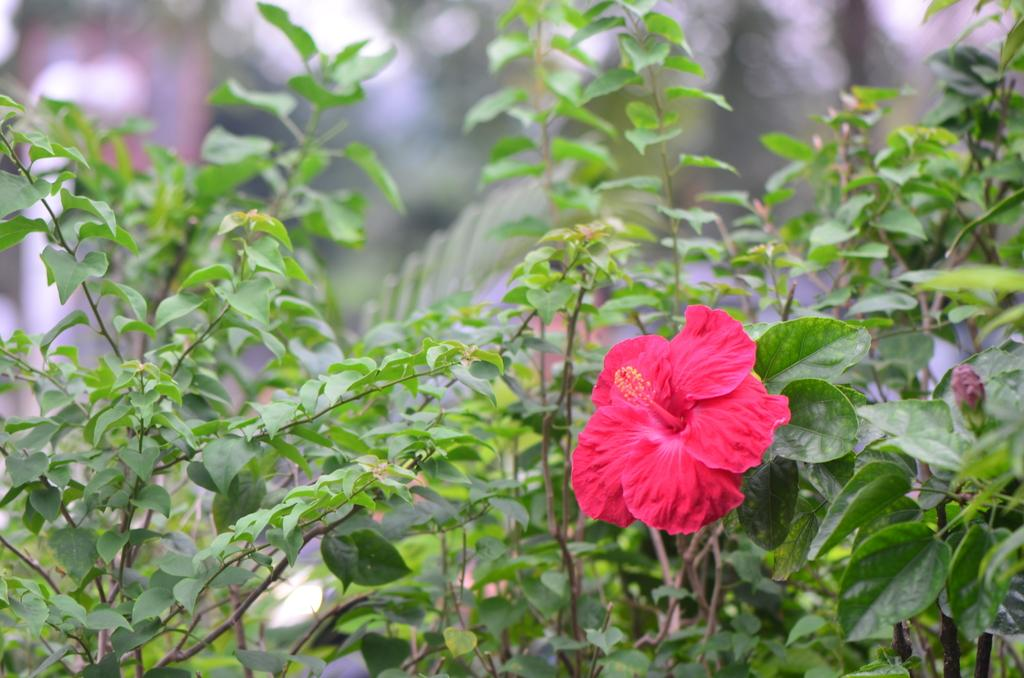What type of flower is present in the image? There is a pink color flower in the image. What is the flower connected to in the image? The flower is associated with plants. Can you describe the background of the image? The background of the image is blurred. What type of cake is being served in the image? There is no cake present in the image; it features a pink color flower associated with plants. 